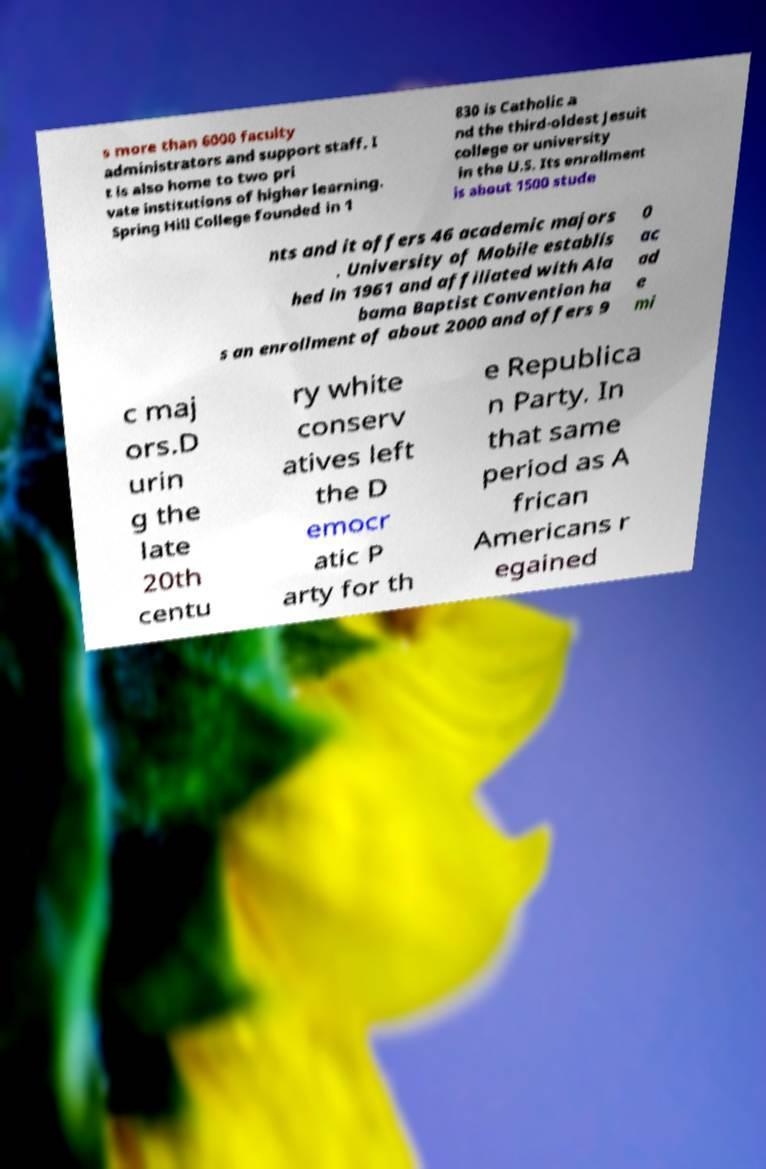Can you read and provide the text displayed in the image?This photo seems to have some interesting text. Can you extract and type it out for me? s more than 6000 faculty administrators and support staff. I t is also home to two pri vate institutions of higher learning. Spring Hill College founded in 1 830 is Catholic a nd the third-oldest Jesuit college or university in the U.S. Its enrollment is about 1500 stude nts and it offers 46 academic majors . University of Mobile establis hed in 1961 and affiliated with Ala bama Baptist Convention ha s an enrollment of about 2000 and offers 9 0 ac ad e mi c maj ors.D urin g the late 20th centu ry white conserv atives left the D emocr atic P arty for th e Republica n Party. In that same period as A frican Americans r egained 